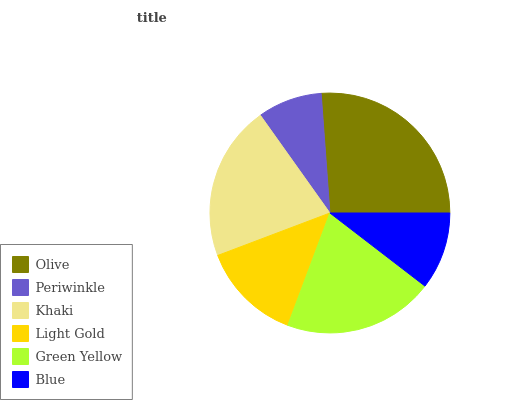Is Periwinkle the minimum?
Answer yes or no. Yes. Is Olive the maximum?
Answer yes or no. Yes. Is Khaki the minimum?
Answer yes or no. No. Is Khaki the maximum?
Answer yes or no. No. Is Khaki greater than Periwinkle?
Answer yes or no. Yes. Is Periwinkle less than Khaki?
Answer yes or no. Yes. Is Periwinkle greater than Khaki?
Answer yes or no. No. Is Khaki less than Periwinkle?
Answer yes or no. No. Is Green Yellow the high median?
Answer yes or no. Yes. Is Light Gold the low median?
Answer yes or no. Yes. Is Light Gold the high median?
Answer yes or no. No. Is Green Yellow the low median?
Answer yes or no. No. 